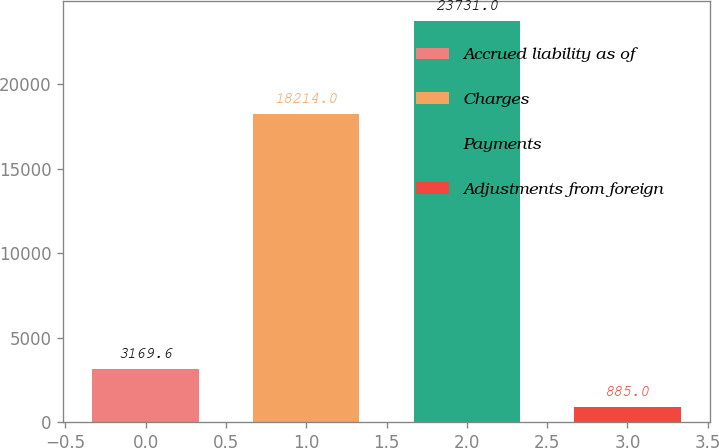Convert chart. <chart><loc_0><loc_0><loc_500><loc_500><bar_chart><fcel>Accrued liability as of<fcel>Charges<fcel>Payments<fcel>Adjustments from foreign<nl><fcel>3169.6<fcel>18214<fcel>23731<fcel>885<nl></chart> 